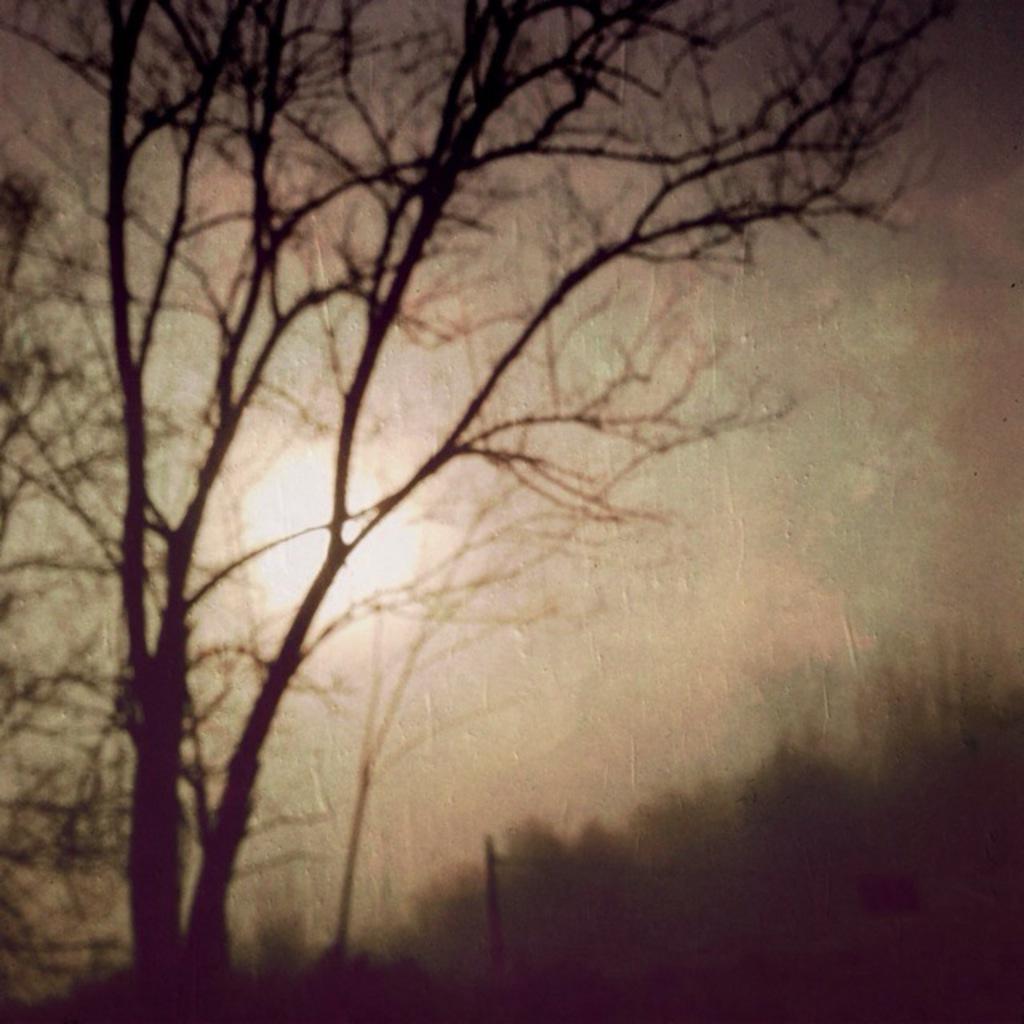Could you give a brief overview of what you see in this image? In this image we can see the picture of a tree, the sun and the sky. 